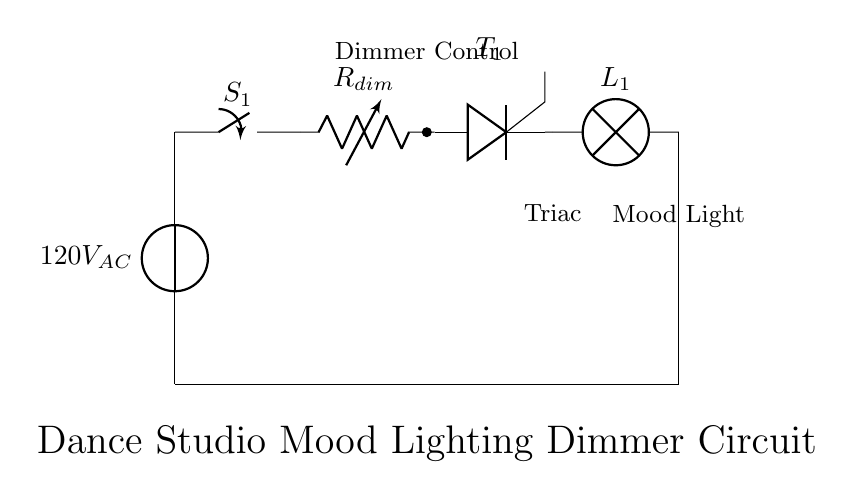What is the voltage in this circuit? The voltage source is labeled as 120V_AC, indicating the potential difference provided for the circuit.
Answer: 120V_AC What component adjusts the light brightness? The variable resistor, labeled as R_dim, is the component designed to adjust the resistance in the circuit, thus controlling the brightness of the light bulb.
Answer: R_dim What type of switch is used in this circuit? The switch is labeled as S_1, indicating it is a simple on/off switch.
Answer: S_1 How many main components are in the circuit? The circuit contains four main components: a voltage source, a dimmer switch, a triac, and a lamp.
Answer: Four Why is a triac used in this circuit? A triac is used to control the power delivered to the lamp by switching on and off quickly, allowing for smooth dimming and varied light intensity.
Answer: For dimming What is the role of the capacitor in a dimmer circuit? There is no capacitor explicitly shown in this circuit diagram. The dimmer relies on the variable resistor and triac for controlling light intensity.
Answer: None What is the expected output of the dimmer circuit? The expected output is mood lighting, which can be adjusted for intensity through the dimmer.
Answer: Mood lighting 